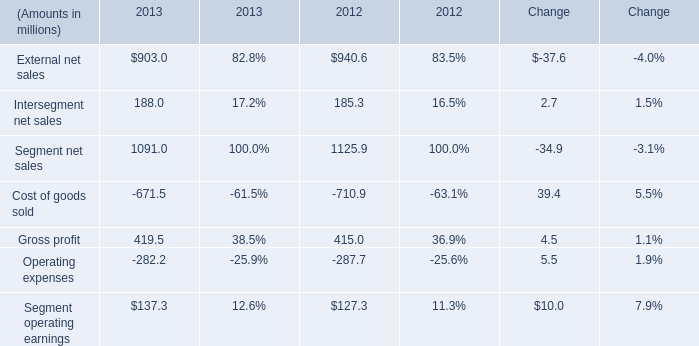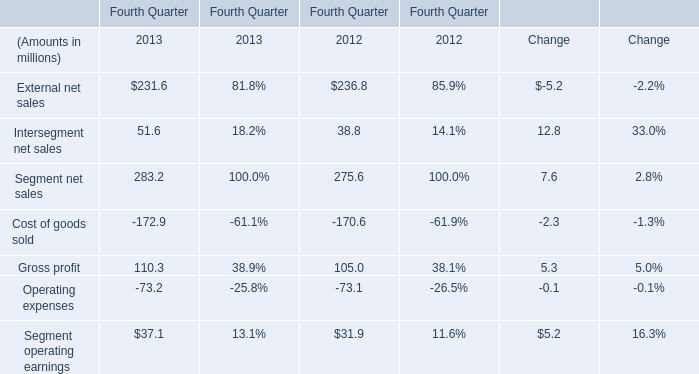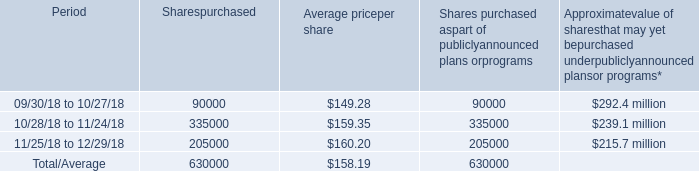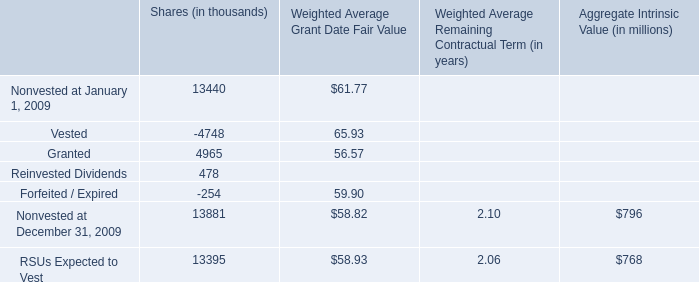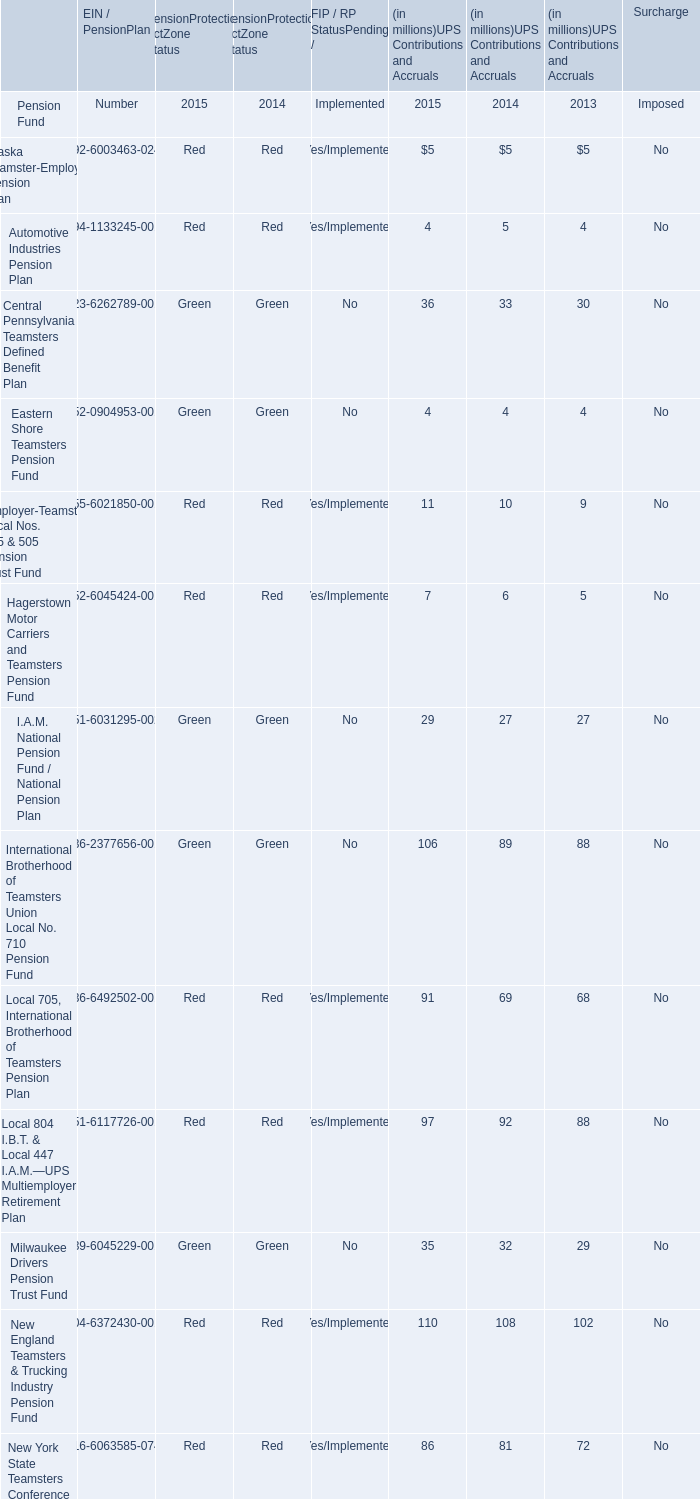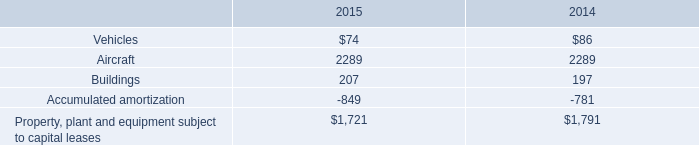In the year with the most Intersegment net sales, what is the growth rate of gross profit? (in %) 
Computations: ((110.3 - 105) / 105)
Answer: 0.05048. 